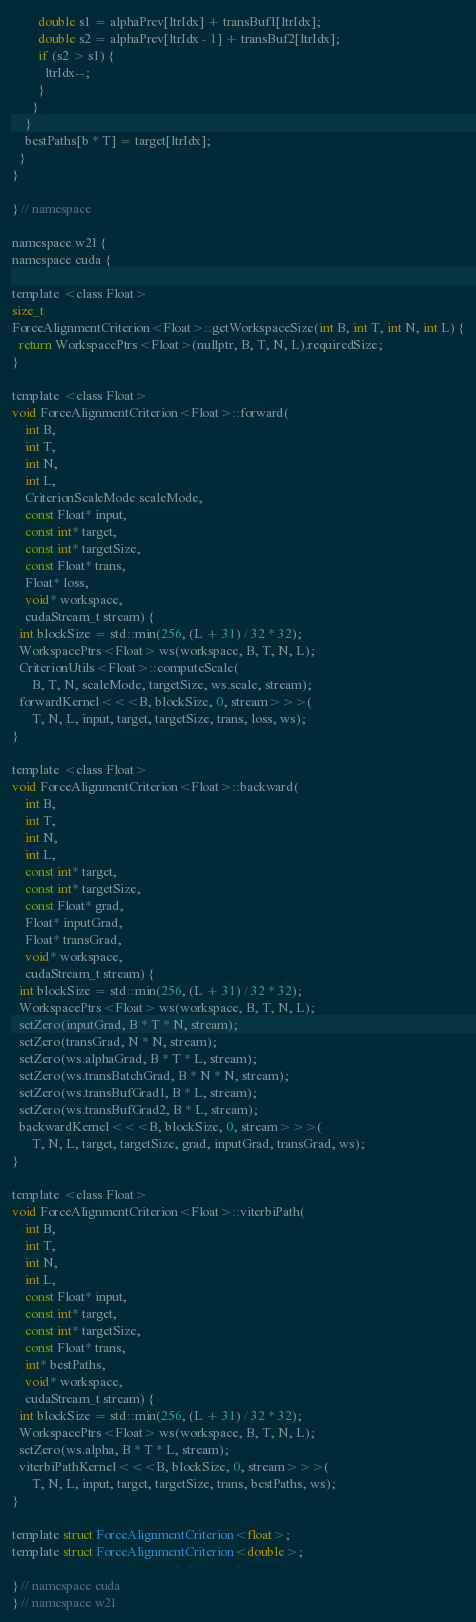<code> <loc_0><loc_0><loc_500><loc_500><_Cuda_>        double s1 = alphaPrev[ltrIdx] + transBuf1[ltrIdx];
        double s2 = alphaPrev[ltrIdx - 1] + transBuf2[ltrIdx];
        if (s2 > s1) {
          ltrIdx--;
        }
      }
    }
    bestPaths[b * T] = target[ltrIdx];
  }
}

} // namespace

namespace w2l {
namespace cuda {

template <class Float>
size_t
ForceAlignmentCriterion<Float>::getWorkspaceSize(int B, int T, int N, int L) {
  return WorkspacePtrs<Float>(nullptr, B, T, N, L).requiredSize;
}

template <class Float>
void ForceAlignmentCriterion<Float>::forward(
    int B,
    int T,
    int N,
    int L,
    CriterionScaleMode scaleMode,
    const Float* input,
    const int* target,
    const int* targetSize,
    const Float* trans,
    Float* loss,
    void* workspace,
    cudaStream_t stream) {
  int blockSize = std::min(256, (L + 31) / 32 * 32);
  WorkspacePtrs<Float> ws(workspace, B, T, N, L);
  CriterionUtils<Float>::computeScale(
      B, T, N, scaleMode, targetSize, ws.scale, stream);
  forwardKernel<<<B, blockSize, 0, stream>>>(
      T, N, L, input, target, targetSize, trans, loss, ws);
}

template <class Float>
void ForceAlignmentCriterion<Float>::backward(
    int B,
    int T,
    int N,
    int L,
    const int* target,
    const int* targetSize,
    const Float* grad,
    Float* inputGrad,
    Float* transGrad,
    void* workspace,
    cudaStream_t stream) {
  int blockSize = std::min(256, (L + 31) / 32 * 32);
  WorkspacePtrs<Float> ws(workspace, B, T, N, L);
  setZero(inputGrad, B * T * N, stream);
  setZero(transGrad, N * N, stream);
  setZero(ws.alphaGrad, B * T * L, stream);
  setZero(ws.transBatchGrad, B * N * N, stream);
  setZero(ws.transBufGrad1, B * L, stream);
  setZero(ws.transBufGrad2, B * L, stream);
  backwardKernel<<<B, blockSize, 0, stream>>>(
      T, N, L, target, targetSize, grad, inputGrad, transGrad, ws);
}

template <class Float>
void ForceAlignmentCriterion<Float>::viterbiPath(
    int B,
    int T,
    int N,
    int L,
    const Float* input,
    const int* target,
    const int* targetSize,
    const Float* trans,
    int* bestPaths,
    void* workspace,
    cudaStream_t stream) {
  int blockSize = std::min(256, (L + 31) / 32 * 32);
  WorkspacePtrs<Float> ws(workspace, B, T, N, L);
  setZero(ws.alpha, B * T * L, stream);
  viterbiPathKernel<<<B, blockSize, 0, stream>>>(
      T, N, L, input, target, targetSize, trans, bestPaths, ws);
}

template struct ForceAlignmentCriterion<float>;
template struct ForceAlignmentCriterion<double>;

} // namespace cuda
} // namespace w2l
</code> 